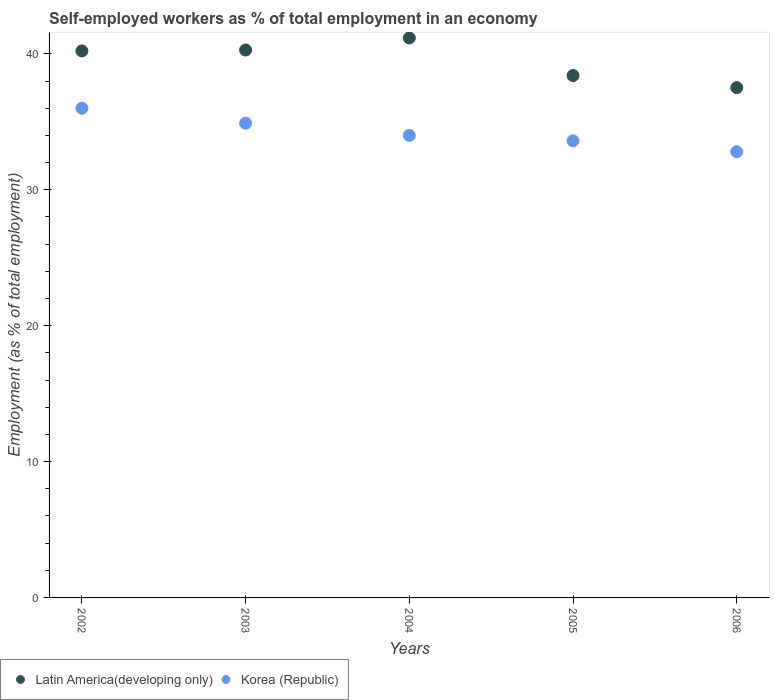How many different coloured dotlines are there?
Provide a succinct answer. 2. What is the percentage of self-employed workers in Latin America(developing only) in 2006?
Ensure brevity in your answer.  37.52. Across all years, what is the maximum percentage of self-employed workers in Latin America(developing only)?
Your answer should be very brief. 41.17. Across all years, what is the minimum percentage of self-employed workers in Korea (Republic)?
Make the answer very short. 32.8. In which year was the percentage of self-employed workers in Latin America(developing only) maximum?
Provide a short and direct response. 2004. What is the total percentage of self-employed workers in Korea (Republic) in the graph?
Provide a short and direct response. 171.3. What is the difference between the percentage of self-employed workers in Korea (Republic) in 2003 and that in 2005?
Give a very brief answer. 1.3. What is the difference between the percentage of self-employed workers in Latin America(developing only) in 2003 and the percentage of self-employed workers in Korea (Republic) in 2005?
Your answer should be very brief. 6.69. What is the average percentage of self-employed workers in Latin America(developing only) per year?
Your answer should be compact. 39.52. In the year 2002, what is the difference between the percentage of self-employed workers in Korea (Republic) and percentage of self-employed workers in Latin America(developing only)?
Make the answer very short. -4.22. In how many years, is the percentage of self-employed workers in Korea (Republic) greater than 20 %?
Your answer should be compact. 5. What is the ratio of the percentage of self-employed workers in Latin America(developing only) in 2004 to that in 2006?
Your answer should be compact. 1.1. Is the percentage of self-employed workers in Korea (Republic) in 2003 less than that in 2005?
Provide a succinct answer. No. What is the difference between the highest and the second highest percentage of self-employed workers in Korea (Republic)?
Ensure brevity in your answer.  1.1. What is the difference between the highest and the lowest percentage of self-employed workers in Latin America(developing only)?
Make the answer very short. 3.66. Does the percentage of self-employed workers in Korea (Republic) monotonically increase over the years?
Your answer should be compact. No. Does the graph contain any zero values?
Your response must be concise. No. Does the graph contain grids?
Make the answer very short. No. How many legend labels are there?
Give a very brief answer. 2. How are the legend labels stacked?
Give a very brief answer. Horizontal. What is the title of the graph?
Offer a terse response. Self-employed workers as % of total employment in an economy. Does "Bermuda" appear as one of the legend labels in the graph?
Your answer should be compact. No. What is the label or title of the X-axis?
Give a very brief answer. Years. What is the label or title of the Y-axis?
Offer a terse response. Employment (as % of total employment). What is the Employment (as % of total employment) in Latin America(developing only) in 2002?
Make the answer very short. 40.22. What is the Employment (as % of total employment) in Korea (Republic) in 2002?
Your answer should be compact. 36. What is the Employment (as % of total employment) of Latin America(developing only) in 2003?
Your response must be concise. 40.29. What is the Employment (as % of total employment) in Korea (Republic) in 2003?
Make the answer very short. 34.9. What is the Employment (as % of total employment) of Latin America(developing only) in 2004?
Your answer should be compact. 41.17. What is the Employment (as % of total employment) of Latin America(developing only) in 2005?
Ensure brevity in your answer.  38.41. What is the Employment (as % of total employment) of Korea (Republic) in 2005?
Your answer should be very brief. 33.6. What is the Employment (as % of total employment) of Latin America(developing only) in 2006?
Ensure brevity in your answer.  37.52. What is the Employment (as % of total employment) of Korea (Republic) in 2006?
Ensure brevity in your answer.  32.8. Across all years, what is the maximum Employment (as % of total employment) of Latin America(developing only)?
Provide a succinct answer. 41.17. Across all years, what is the minimum Employment (as % of total employment) in Latin America(developing only)?
Give a very brief answer. 37.52. Across all years, what is the minimum Employment (as % of total employment) in Korea (Republic)?
Offer a terse response. 32.8. What is the total Employment (as % of total employment) of Latin America(developing only) in the graph?
Provide a succinct answer. 197.6. What is the total Employment (as % of total employment) of Korea (Republic) in the graph?
Your answer should be very brief. 171.3. What is the difference between the Employment (as % of total employment) in Latin America(developing only) in 2002 and that in 2003?
Your response must be concise. -0.07. What is the difference between the Employment (as % of total employment) of Korea (Republic) in 2002 and that in 2003?
Give a very brief answer. 1.1. What is the difference between the Employment (as % of total employment) in Latin America(developing only) in 2002 and that in 2004?
Make the answer very short. -0.95. What is the difference between the Employment (as % of total employment) of Latin America(developing only) in 2002 and that in 2005?
Give a very brief answer. 1.81. What is the difference between the Employment (as % of total employment) of Latin America(developing only) in 2002 and that in 2006?
Offer a terse response. 2.7. What is the difference between the Employment (as % of total employment) in Korea (Republic) in 2002 and that in 2006?
Offer a terse response. 3.2. What is the difference between the Employment (as % of total employment) of Latin America(developing only) in 2003 and that in 2004?
Your answer should be very brief. -0.89. What is the difference between the Employment (as % of total employment) in Latin America(developing only) in 2003 and that in 2005?
Offer a terse response. 1.88. What is the difference between the Employment (as % of total employment) in Latin America(developing only) in 2003 and that in 2006?
Ensure brevity in your answer.  2.77. What is the difference between the Employment (as % of total employment) in Latin America(developing only) in 2004 and that in 2005?
Your answer should be very brief. 2.76. What is the difference between the Employment (as % of total employment) of Latin America(developing only) in 2004 and that in 2006?
Your response must be concise. 3.66. What is the difference between the Employment (as % of total employment) of Latin America(developing only) in 2005 and that in 2006?
Keep it short and to the point. 0.89. What is the difference between the Employment (as % of total employment) of Korea (Republic) in 2005 and that in 2006?
Give a very brief answer. 0.8. What is the difference between the Employment (as % of total employment) in Latin America(developing only) in 2002 and the Employment (as % of total employment) in Korea (Republic) in 2003?
Your answer should be very brief. 5.32. What is the difference between the Employment (as % of total employment) of Latin America(developing only) in 2002 and the Employment (as % of total employment) of Korea (Republic) in 2004?
Provide a short and direct response. 6.22. What is the difference between the Employment (as % of total employment) in Latin America(developing only) in 2002 and the Employment (as % of total employment) in Korea (Republic) in 2005?
Give a very brief answer. 6.62. What is the difference between the Employment (as % of total employment) of Latin America(developing only) in 2002 and the Employment (as % of total employment) of Korea (Republic) in 2006?
Offer a very short reply. 7.42. What is the difference between the Employment (as % of total employment) of Latin America(developing only) in 2003 and the Employment (as % of total employment) of Korea (Republic) in 2004?
Ensure brevity in your answer.  6.29. What is the difference between the Employment (as % of total employment) of Latin America(developing only) in 2003 and the Employment (as % of total employment) of Korea (Republic) in 2005?
Your answer should be compact. 6.69. What is the difference between the Employment (as % of total employment) of Latin America(developing only) in 2003 and the Employment (as % of total employment) of Korea (Republic) in 2006?
Your response must be concise. 7.49. What is the difference between the Employment (as % of total employment) of Latin America(developing only) in 2004 and the Employment (as % of total employment) of Korea (Republic) in 2005?
Offer a terse response. 7.57. What is the difference between the Employment (as % of total employment) of Latin America(developing only) in 2004 and the Employment (as % of total employment) of Korea (Republic) in 2006?
Provide a short and direct response. 8.37. What is the difference between the Employment (as % of total employment) in Latin America(developing only) in 2005 and the Employment (as % of total employment) in Korea (Republic) in 2006?
Provide a short and direct response. 5.61. What is the average Employment (as % of total employment) in Latin America(developing only) per year?
Ensure brevity in your answer.  39.52. What is the average Employment (as % of total employment) in Korea (Republic) per year?
Your answer should be compact. 34.26. In the year 2002, what is the difference between the Employment (as % of total employment) in Latin America(developing only) and Employment (as % of total employment) in Korea (Republic)?
Provide a short and direct response. 4.22. In the year 2003, what is the difference between the Employment (as % of total employment) in Latin America(developing only) and Employment (as % of total employment) in Korea (Republic)?
Your response must be concise. 5.39. In the year 2004, what is the difference between the Employment (as % of total employment) of Latin America(developing only) and Employment (as % of total employment) of Korea (Republic)?
Ensure brevity in your answer.  7.17. In the year 2005, what is the difference between the Employment (as % of total employment) in Latin America(developing only) and Employment (as % of total employment) in Korea (Republic)?
Keep it short and to the point. 4.81. In the year 2006, what is the difference between the Employment (as % of total employment) in Latin America(developing only) and Employment (as % of total employment) in Korea (Republic)?
Provide a short and direct response. 4.72. What is the ratio of the Employment (as % of total employment) in Latin America(developing only) in 2002 to that in 2003?
Give a very brief answer. 1. What is the ratio of the Employment (as % of total employment) of Korea (Republic) in 2002 to that in 2003?
Keep it short and to the point. 1.03. What is the ratio of the Employment (as % of total employment) in Latin America(developing only) in 2002 to that in 2004?
Offer a very short reply. 0.98. What is the ratio of the Employment (as % of total employment) of Korea (Republic) in 2002 to that in 2004?
Offer a terse response. 1.06. What is the ratio of the Employment (as % of total employment) in Latin America(developing only) in 2002 to that in 2005?
Provide a succinct answer. 1.05. What is the ratio of the Employment (as % of total employment) of Korea (Republic) in 2002 to that in 2005?
Your answer should be very brief. 1.07. What is the ratio of the Employment (as % of total employment) of Latin America(developing only) in 2002 to that in 2006?
Offer a terse response. 1.07. What is the ratio of the Employment (as % of total employment) in Korea (Republic) in 2002 to that in 2006?
Ensure brevity in your answer.  1.1. What is the ratio of the Employment (as % of total employment) in Latin America(developing only) in 2003 to that in 2004?
Make the answer very short. 0.98. What is the ratio of the Employment (as % of total employment) in Korea (Republic) in 2003 to that in 2004?
Offer a terse response. 1.03. What is the ratio of the Employment (as % of total employment) in Latin America(developing only) in 2003 to that in 2005?
Ensure brevity in your answer.  1.05. What is the ratio of the Employment (as % of total employment) of Korea (Republic) in 2003 to that in 2005?
Offer a very short reply. 1.04. What is the ratio of the Employment (as % of total employment) in Latin America(developing only) in 2003 to that in 2006?
Make the answer very short. 1.07. What is the ratio of the Employment (as % of total employment) in Korea (Republic) in 2003 to that in 2006?
Provide a succinct answer. 1.06. What is the ratio of the Employment (as % of total employment) of Latin America(developing only) in 2004 to that in 2005?
Offer a very short reply. 1.07. What is the ratio of the Employment (as % of total employment) of Korea (Republic) in 2004 to that in 2005?
Provide a succinct answer. 1.01. What is the ratio of the Employment (as % of total employment) of Latin America(developing only) in 2004 to that in 2006?
Your answer should be compact. 1.1. What is the ratio of the Employment (as % of total employment) of Korea (Republic) in 2004 to that in 2006?
Your answer should be very brief. 1.04. What is the ratio of the Employment (as % of total employment) of Latin America(developing only) in 2005 to that in 2006?
Your response must be concise. 1.02. What is the ratio of the Employment (as % of total employment) in Korea (Republic) in 2005 to that in 2006?
Provide a succinct answer. 1.02. What is the difference between the highest and the second highest Employment (as % of total employment) of Latin America(developing only)?
Make the answer very short. 0.89. What is the difference between the highest and the lowest Employment (as % of total employment) of Latin America(developing only)?
Give a very brief answer. 3.66. What is the difference between the highest and the lowest Employment (as % of total employment) in Korea (Republic)?
Keep it short and to the point. 3.2. 